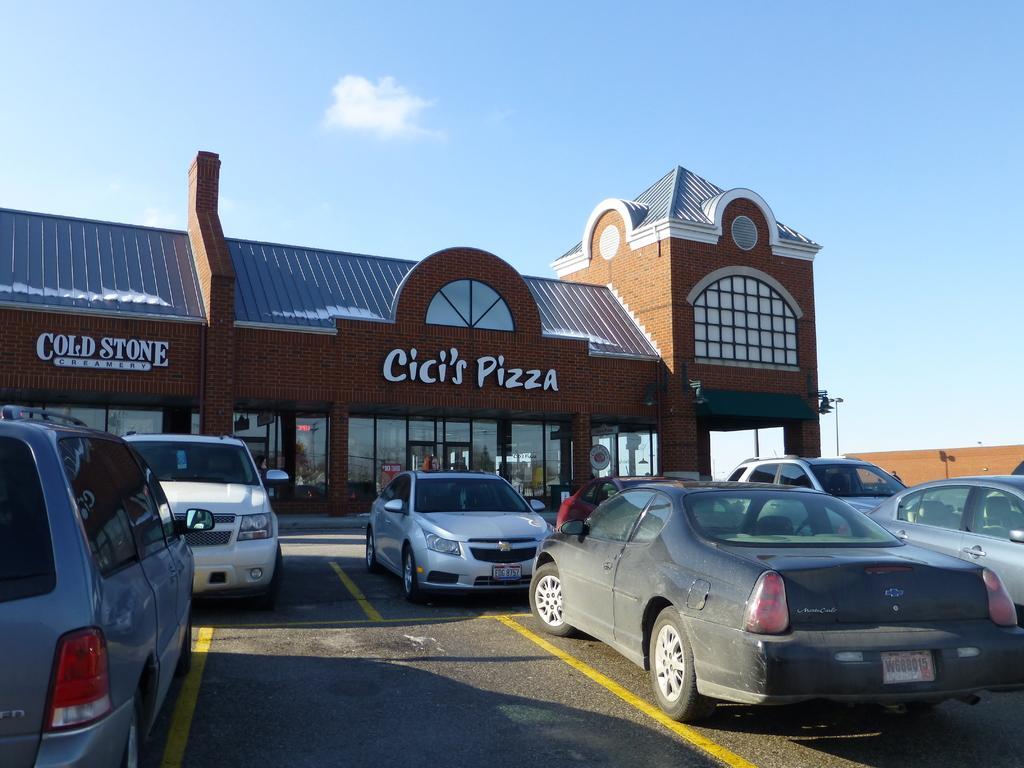Describe this image in one or two sentences. In this picture I can see there are few cars parked here and there is a building in the backdrop and there is a name plate on the building with windows. The sky is clear. 